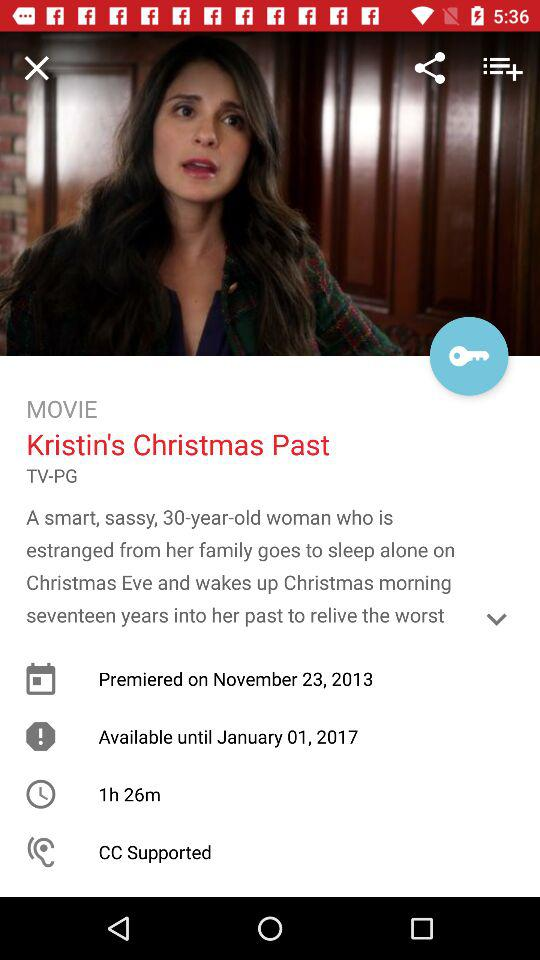Until what date will the movie be available? The movie will be available until January 1, 2017. 